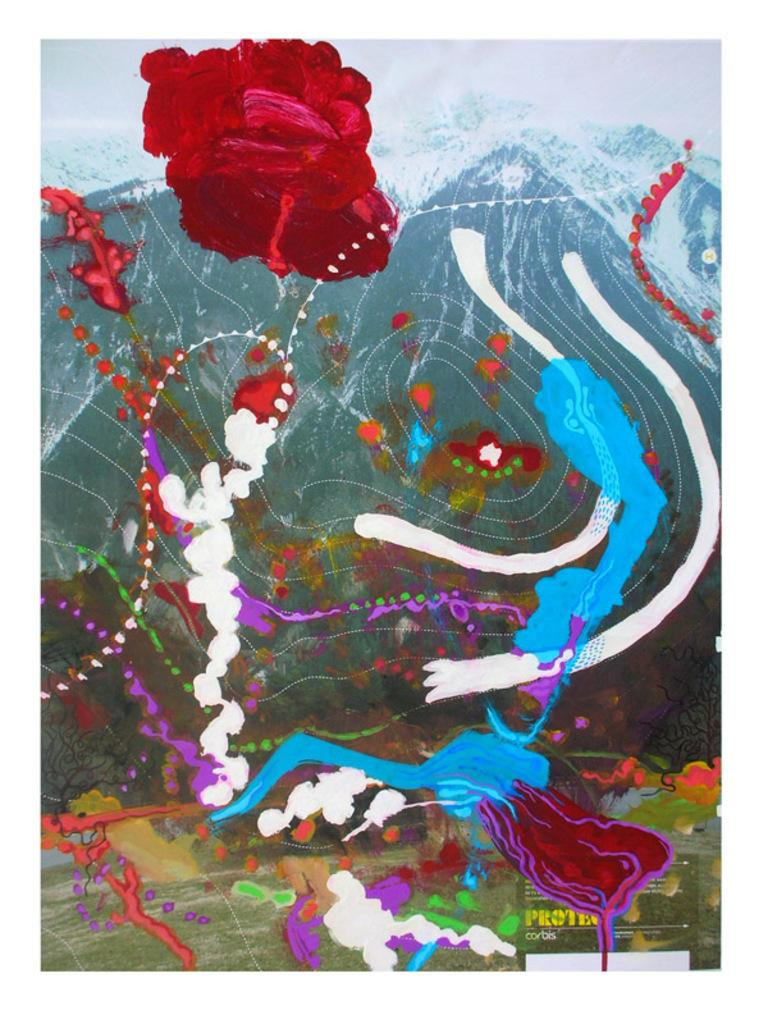What is featured on the poster in the image? There is a painting on a poster in the image. What is the subject of the painting? The painting depicts mountains. How many bushes are visible in the painting? There is no mention of bushes in the painting; it depicts mountains. What type of pen is used to create the painting? The painting is not a physical object, so it cannot be determined what type of pen was used to create it. 